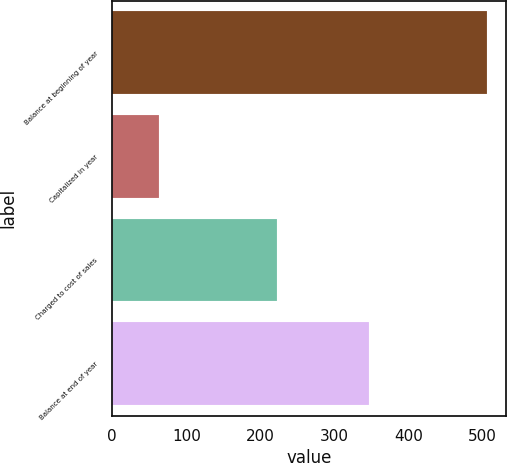<chart> <loc_0><loc_0><loc_500><loc_500><bar_chart><fcel>Balance at beginning of year<fcel>Capitalized in year<fcel>Charged to cost of sales<fcel>Balance at end of year<nl><fcel>506<fcel>63<fcel>222<fcel>347<nl></chart> 